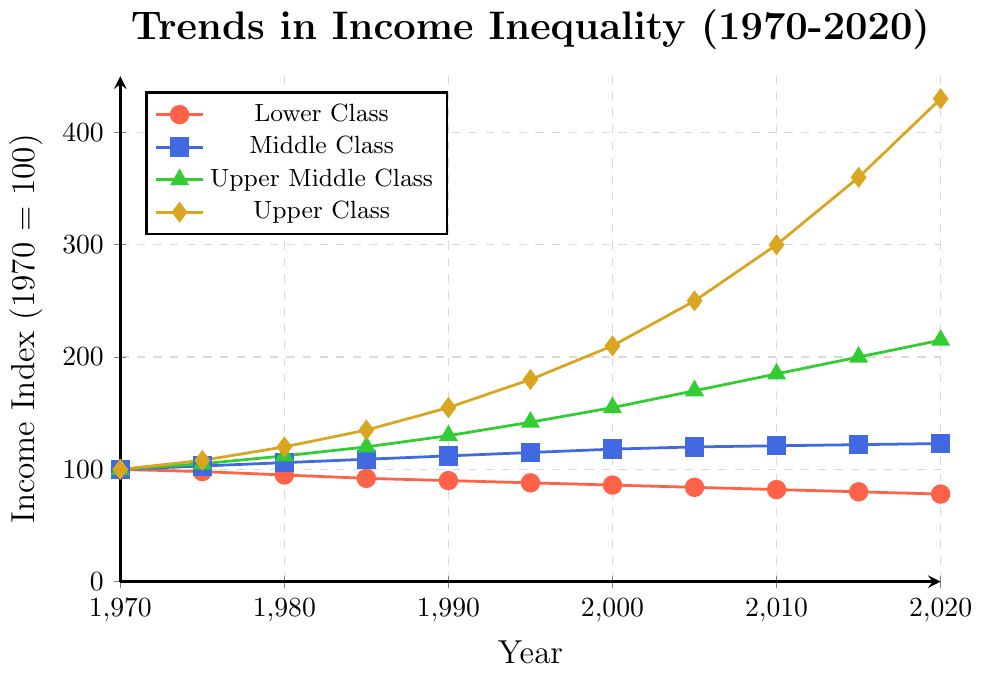What is the income index difference between the Upper Class and Lower Class in 2020? First, find the data points for the Upper Class (430) and Lower Class (78) in 2020. Then, subtract the Lower Class value from the Upper Class value (430 - 78).
Answer: 352 Which class saw the steepest increase in income index between 1970 and 2020? Compare the increases for all classes: Lower Class decreased (100 to 78), Middle Class increased marginally (100 to 123), Upper Middle Class increased significantly (100 to 215), and Upper Class increased the most (100 to 430). The steepest increase is from the Upper Class.
Answer: Upper Class By how much did the Middle Class income index rise from 1970 to 2000? Identify the Middle Class data points in 1970 (100) and 2000 (118). Subtract the earlier value from the later value (118 - 100).
Answer: 18 Between which two decades did the Lower Class experience the largest decline in income index? Compare the differences for each decade: 1970-1980 (100 to 95, -5), 1980-1990 (95 to 90, -5), 1990-2000 (90 to 86, -4), 2000-2010 (86 to 82, -4), 2010-2020 (82 to 78, -4). The largest decline occurred between 1970 and 1980.
Answer: 1970 and 1980 Which year shows the income index for the Middle Class crossing 120? Identify the year where the Middle Class income index is first greater than 120. According to the data, this happens in 2005.
Answer: 2005 What is the average income index for the Upper Middle Class over the 50 years? Sum the income index values for the Upper Middle Class across all years (100 + 105 + 112 + 120 + 130 + 142 + 155 + 170 + 185 + 200 + 215) = 1634. Divide by the number of data points, which is 11 (1634 / 11).
Answer: 148.55 How many classes had an income index greater than 150 in 2020? For 2020, check the values: Lower Class (78), Middle Class (123), Upper Middle Class (215), Upper Class (430). Two classes, Upper Middle Class and Upper Class, have values greater than 150.
Answer: 2 What is the trend of income inequality illustrated by the figure? The plot shows a growing gap, where the Upper Class sees a substantial increase in income index, while the Lower Class experiences a decrease, and the Middle and Upper Middle Classes see moderate increases.
Answer: Growing inequality Which class almost maintained a stable income index over the years and what is the slight change estimated from the figure? The Middle Class shows the most stable trend. Compare 1970 (100) to 2020 (123). Calculate the change (123 - 100).
Answer: Middle Class, 23 What is the income index ratio of the Upper Class to the Lower Class in 2010? Use data points for 2010: Upper Class (300) and Lower Class (82). Calculate the ratio (300 / 82).
Answer: 3.66 